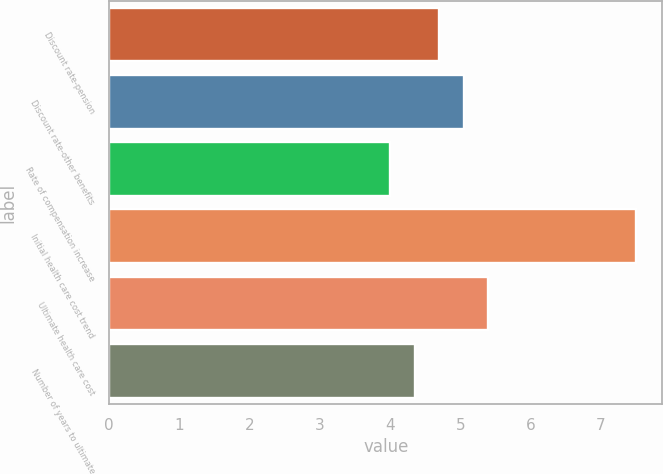Convert chart to OTSL. <chart><loc_0><loc_0><loc_500><loc_500><bar_chart><fcel>Discount rate-pension<fcel>Discount rate-other benefits<fcel>Rate of compensation increase<fcel>Initial health care cost trend<fcel>Ultimate health care cost<fcel>Number of years to ultimate<nl><fcel>4.7<fcel>5.05<fcel>4<fcel>7.5<fcel>5.4<fcel>4.35<nl></chart> 